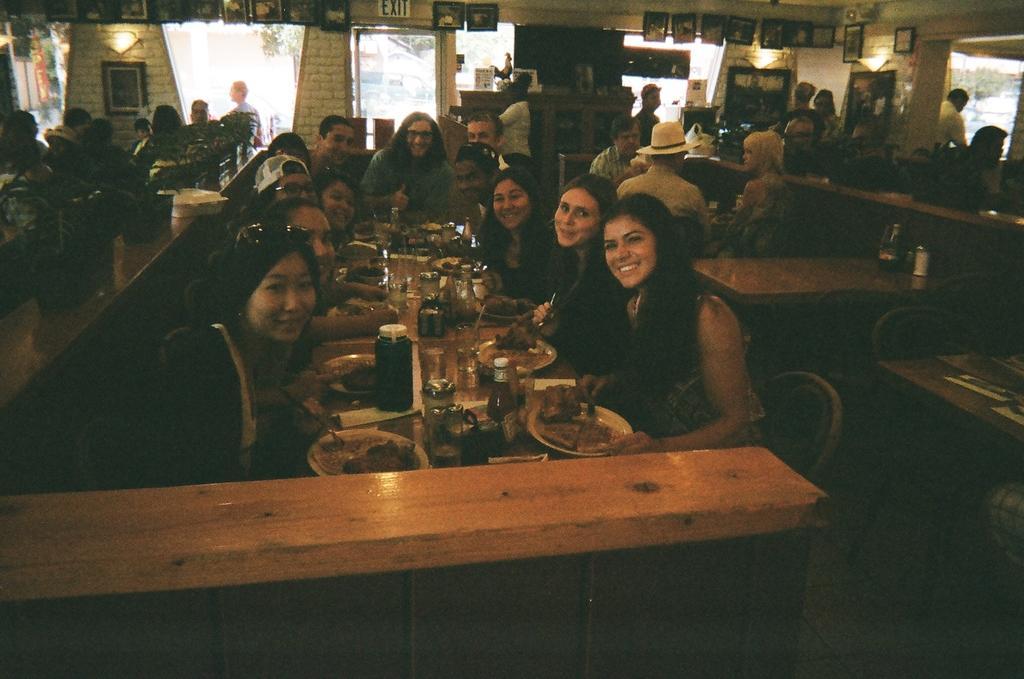Can you describe this image briefly? In this picture we can observe some people sitting in the chairs around the table. There is some food, glasses and some bottles on the table. We can observe men and women in this picture. We can observe a photo frame fixed to the wall. In the background there are trees. 